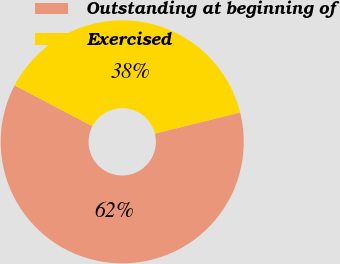Convert chart. <chart><loc_0><loc_0><loc_500><loc_500><pie_chart><fcel>Outstanding at beginning of<fcel>Exercised<nl><fcel>61.58%<fcel>38.42%<nl></chart> 